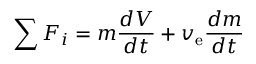Convert formula to latex. <formula><loc_0><loc_0><loc_500><loc_500>\sum F _ { i } = m { \frac { d V } { d t } } + v _ { e } { \frac { d m } { d t } }</formula> 